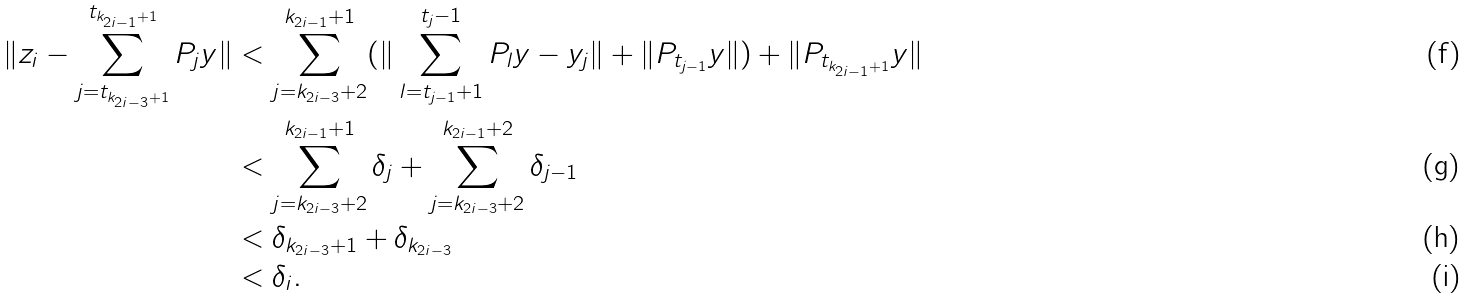<formula> <loc_0><loc_0><loc_500><loc_500>\| z _ { i } - \sum _ { j = t _ { k _ { 2 i - 3 } + 1 } } ^ { t _ { k _ { 2 i - 1 } + 1 } } P _ { j } y \| & < \sum _ { j = k _ { 2 i - 3 } + 2 } ^ { k _ { 2 i - 1 } + 1 } ( \| \sum _ { l = t _ { j - 1 } + 1 } ^ { t _ { j } - 1 } P _ { l } y - y _ { j } \| + \| P _ { t _ { j - 1 } } y \| ) + \| P _ { t _ { k _ { 2 i - 1 } + 1 } } y \| \\ & < \sum _ { j = k _ { 2 i - 3 } + 2 } ^ { k _ { 2 i - 1 } + 1 } \delta _ { j } + \sum _ { j = k _ { 2 i - 3 } + 2 } ^ { k _ { 2 i - 1 } + 2 } \delta _ { j - 1 } \\ & < \delta _ { k _ { 2 i - 3 } + 1 } + \delta _ { k _ { 2 i - 3 } } \\ & < \delta _ { i } .</formula> 